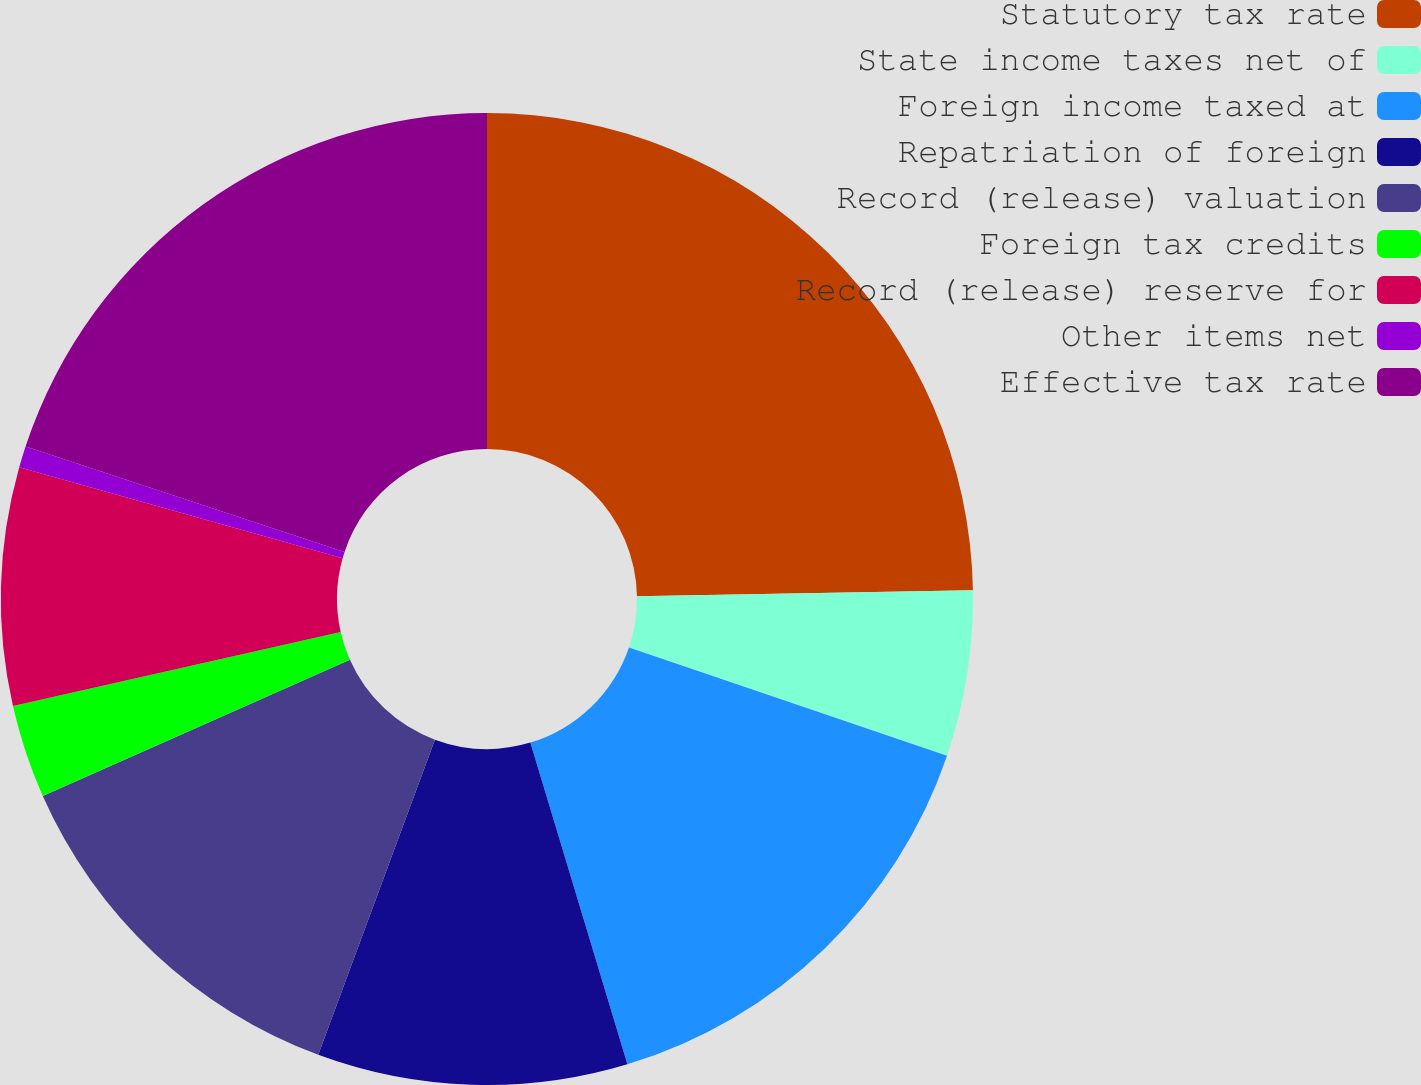Convert chart to OTSL. <chart><loc_0><loc_0><loc_500><loc_500><pie_chart><fcel>Statutory tax rate<fcel>State income taxes net of<fcel>Foreign income taxed at<fcel>Repatriation of foreign<fcel>Record (release) valuation<fcel>Foreign tax credits<fcel>Record (release) reserve for<fcel>Other items net<fcel>Effective tax rate<nl><fcel>24.72%<fcel>5.51%<fcel>15.11%<fcel>10.31%<fcel>12.71%<fcel>3.11%<fcel>7.91%<fcel>0.71%<fcel>19.92%<nl></chart> 